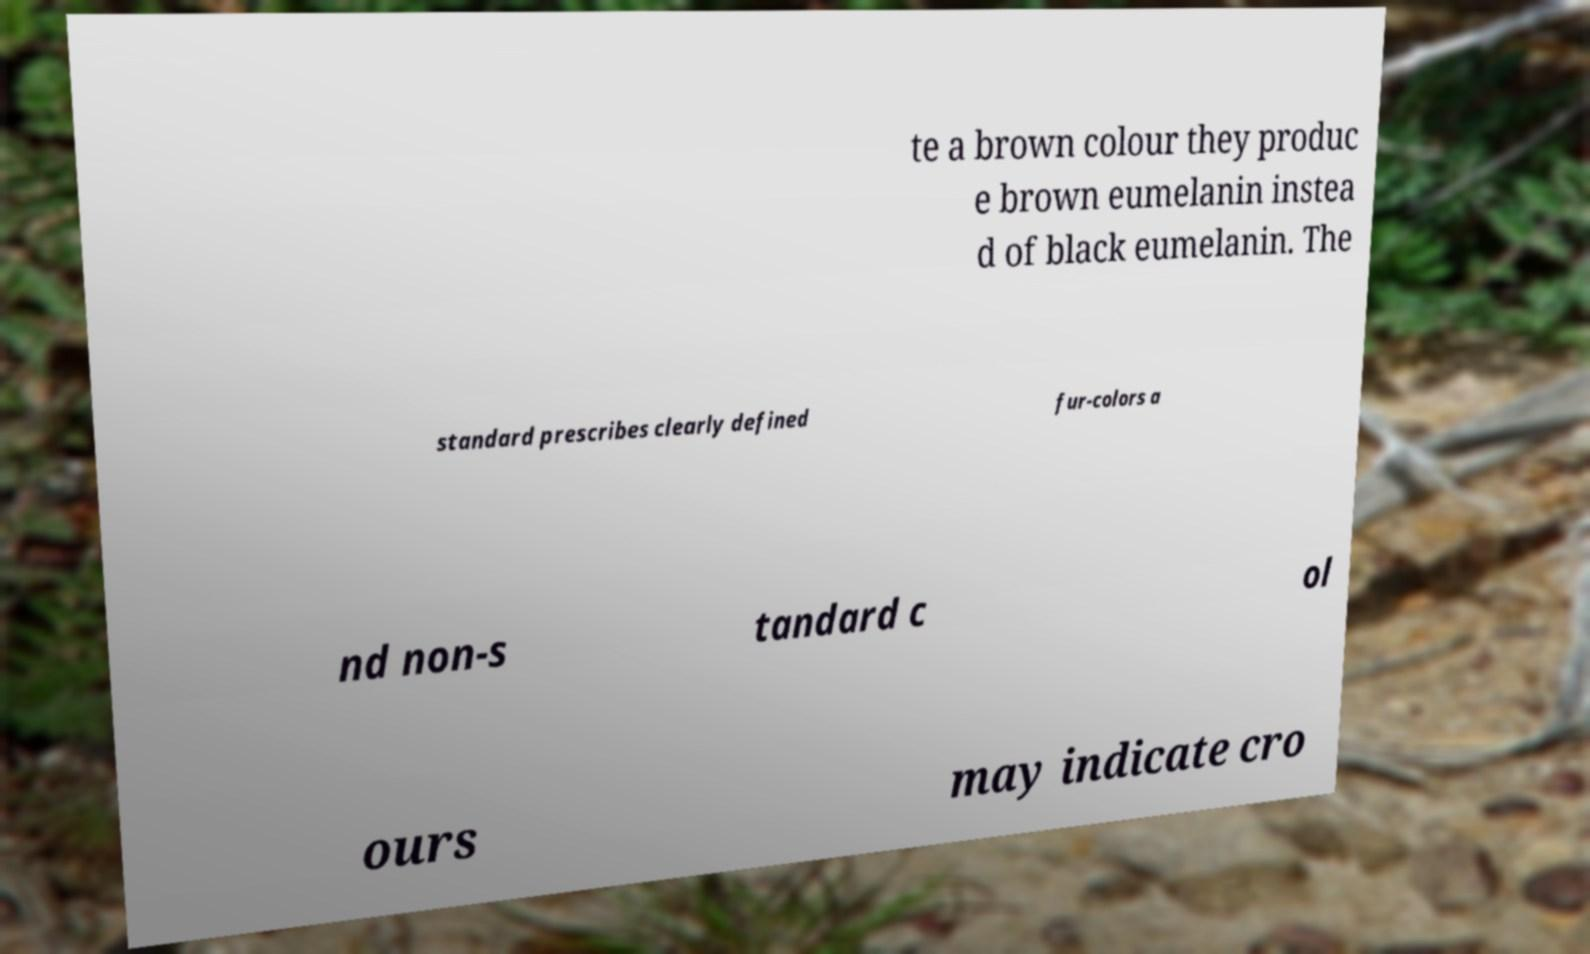What messages or text are displayed in this image? I need them in a readable, typed format. te a brown colour they produc e brown eumelanin instea d of black eumelanin. The standard prescribes clearly defined fur-colors a nd non-s tandard c ol ours may indicate cro 